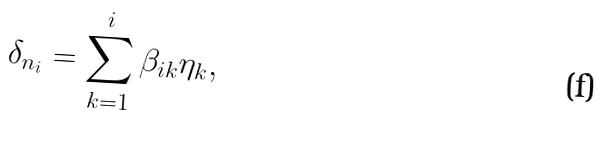Convert formula to latex. <formula><loc_0><loc_0><loc_500><loc_500>\delta _ { n _ { i } } = \sum _ { k = 1 } ^ { i } \beta _ { i k } \eta _ { k } ,</formula> 